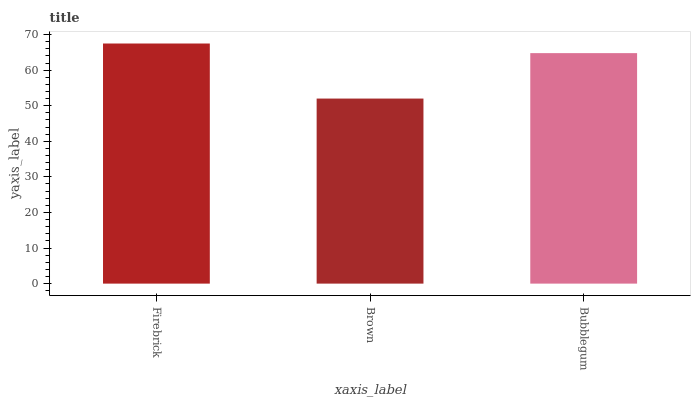Is Brown the minimum?
Answer yes or no. Yes. Is Firebrick the maximum?
Answer yes or no. Yes. Is Bubblegum the minimum?
Answer yes or no. No. Is Bubblegum the maximum?
Answer yes or no. No. Is Bubblegum greater than Brown?
Answer yes or no. Yes. Is Brown less than Bubblegum?
Answer yes or no. Yes. Is Brown greater than Bubblegum?
Answer yes or no. No. Is Bubblegum less than Brown?
Answer yes or no. No. Is Bubblegum the high median?
Answer yes or no. Yes. Is Bubblegum the low median?
Answer yes or no. Yes. Is Firebrick the high median?
Answer yes or no. No. Is Firebrick the low median?
Answer yes or no. No. 